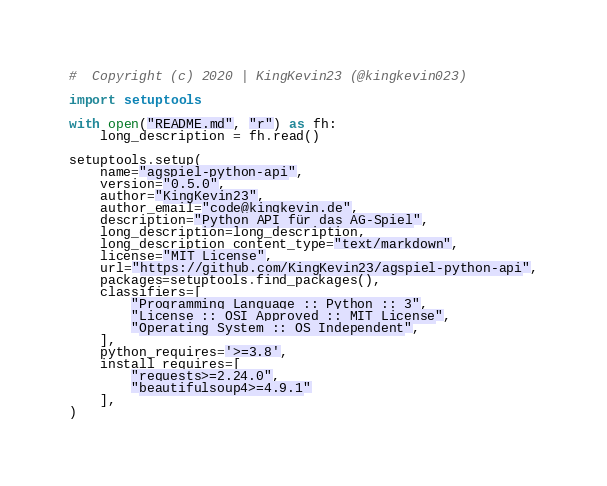<code> <loc_0><loc_0><loc_500><loc_500><_Python_>#  Copyright (c) 2020 | KingKevin23 (@kingkevin023)

import setuptools

with open("README.md", "r") as fh:
    long_description = fh.read()

setuptools.setup(
    name="agspiel-python-api",
    version="0.5.0",
    author="KingKevin23",
    author_email="code@kingkevin.de",
    description="Python API für das AG-Spiel",
    long_description=long_description,
    long_description_content_type="text/markdown",
    license="MIT License",
    url="https://github.com/KingKevin23/agspiel-python-api",
    packages=setuptools.find_packages(),
    classifiers=[
        "Programming Language :: Python :: 3",
        "License :: OSI Approved :: MIT License",
        "Operating System :: OS Independent",
    ],
    python_requires='>=3.8',
    install_requires=[
        "requests>=2.24.0",
        "beautifulsoup4>=4.9.1"
    ],
)</code> 